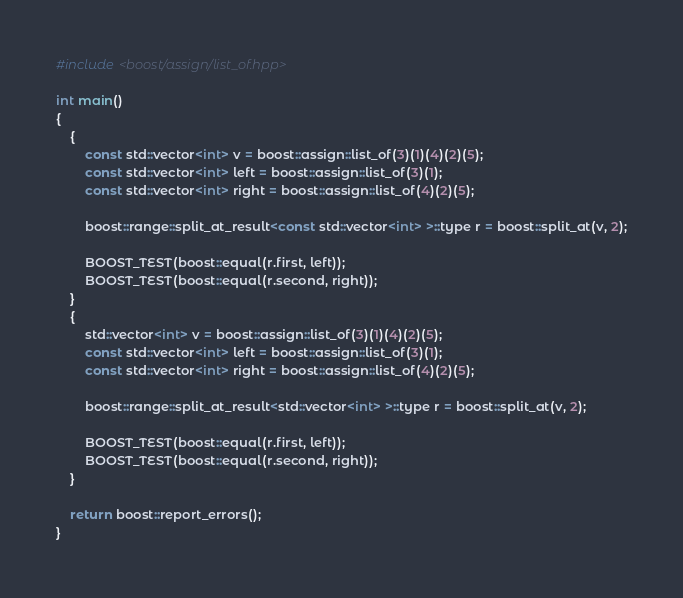<code> <loc_0><loc_0><loc_500><loc_500><_C++_>#include <boost/assign/list_of.hpp>

int main()
{
    {
        const std::vector<int> v = boost::assign::list_of(3)(1)(4)(2)(5);
        const std::vector<int> left = boost::assign::list_of(3)(1);
        const std::vector<int> right = boost::assign::list_of(4)(2)(5);

        boost::range::split_at_result<const std::vector<int> >::type r = boost::split_at(v, 2);

        BOOST_TEST(boost::equal(r.first, left));
        BOOST_TEST(boost::equal(r.second, right));
    }
    {
        std::vector<int> v = boost::assign::list_of(3)(1)(4)(2)(5);
        const std::vector<int> left = boost::assign::list_of(3)(1);
        const std::vector<int> right = boost::assign::list_of(4)(2)(5);

        boost::range::split_at_result<std::vector<int> >::type r = boost::split_at(v, 2);

        BOOST_TEST(boost::equal(r.first, left));
        BOOST_TEST(boost::equal(r.second, right));
    }

    return boost::report_errors();
}


</code> 